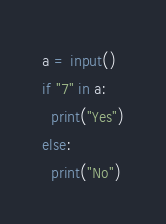Convert code to text. <code><loc_0><loc_0><loc_500><loc_500><_Python_>a = input()
if "7" in a:
  print("Yes")
else:
  print("No")</code> 